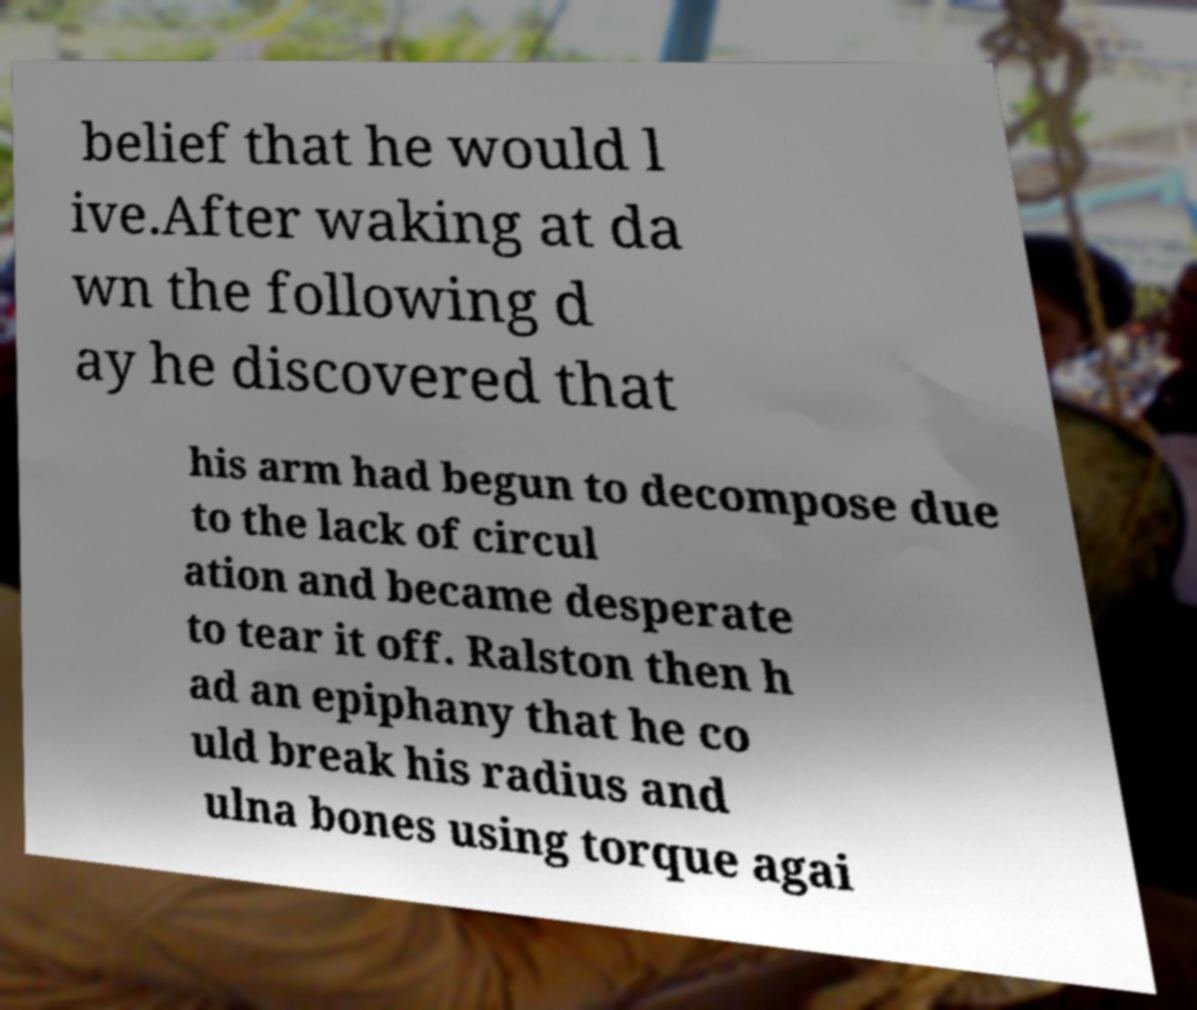Please identify and transcribe the text found in this image. belief that he would l ive.After waking at da wn the following d ay he discovered that his arm had begun to decompose due to the lack of circul ation and became desperate to tear it off. Ralston then h ad an epiphany that he co uld break his radius and ulna bones using torque agai 